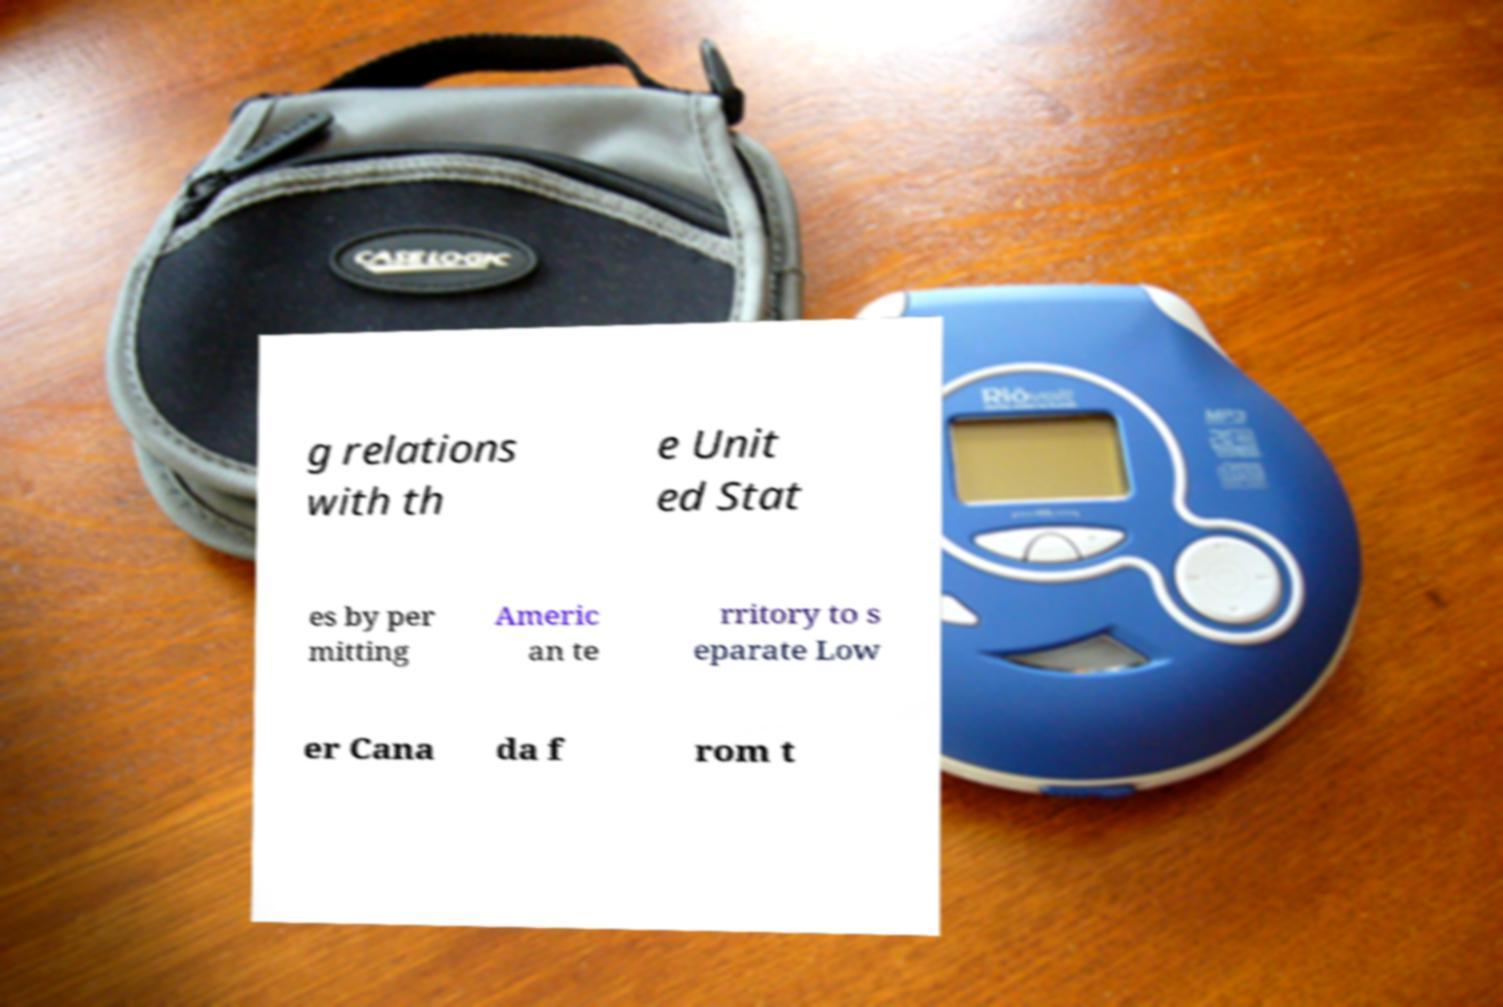Please identify and transcribe the text found in this image. g relations with th e Unit ed Stat es by per mitting Americ an te rritory to s eparate Low er Cana da f rom t 